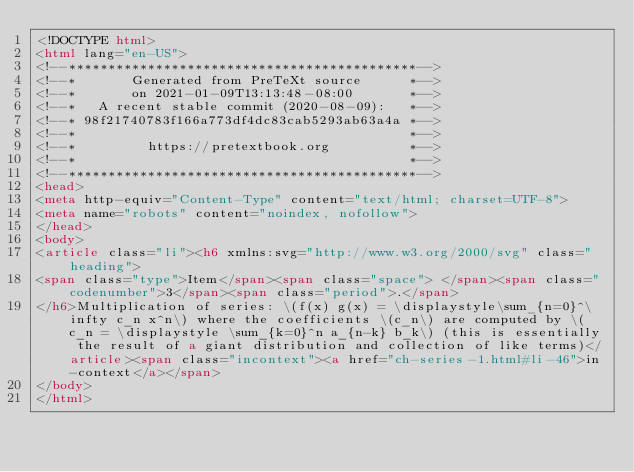<code> <loc_0><loc_0><loc_500><loc_500><_HTML_><!DOCTYPE html>
<html lang="en-US">
<!--********************************************-->
<!--*       Generated from PreTeXt source      *-->
<!--*       on 2021-01-09T13:13:48-08:00       *-->
<!--*   A recent stable commit (2020-08-09):   *-->
<!--* 98f21740783f166a773df4dc83cab5293ab63a4a *-->
<!--*                                          *-->
<!--*         https://pretextbook.org          *-->
<!--*                                          *-->
<!--********************************************-->
<head>
<meta http-equiv="Content-Type" content="text/html; charset=UTF-8">
<meta name="robots" content="noindex, nofollow">
</head>
<body>
<article class="li"><h6 xmlns:svg="http://www.w3.org/2000/svg" class="heading">
<span class="type">Item</span><span class="space"> </span><span class="codenumber">3</span><span class="period">.</span>
</h6>Multiplication of series: \(f(x) g(x) = \displaystyle\sum_{n=0}^\infty c_n x^n\) where the coefficients \(c_n\) are computed by \(c_n = \displaystyle \sum_{k=0}^n a_{n-k} b_k\) (this is essentially the result of a giant distribution and collection of like terms)</article><span class="incontext"><a href="ch-series-1.html#li-46">in-context</a></span>
</body>
</html>
</code> 